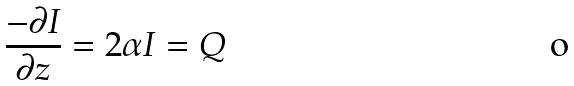Convert formula to latex. <formula><loc_0><loc_0><loc_500><loc_500>\frac { - \partial I } { \partial z } = 2 \alpha I = Q</formula> 